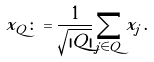<formula> <loc_0><loc_0><loc_500><loc_500>x _ { Q } \colon = \frac { 1 } { \sqrt { | Q | } } \sum _ { j \in Q } x _ { j } \, .</formula> 